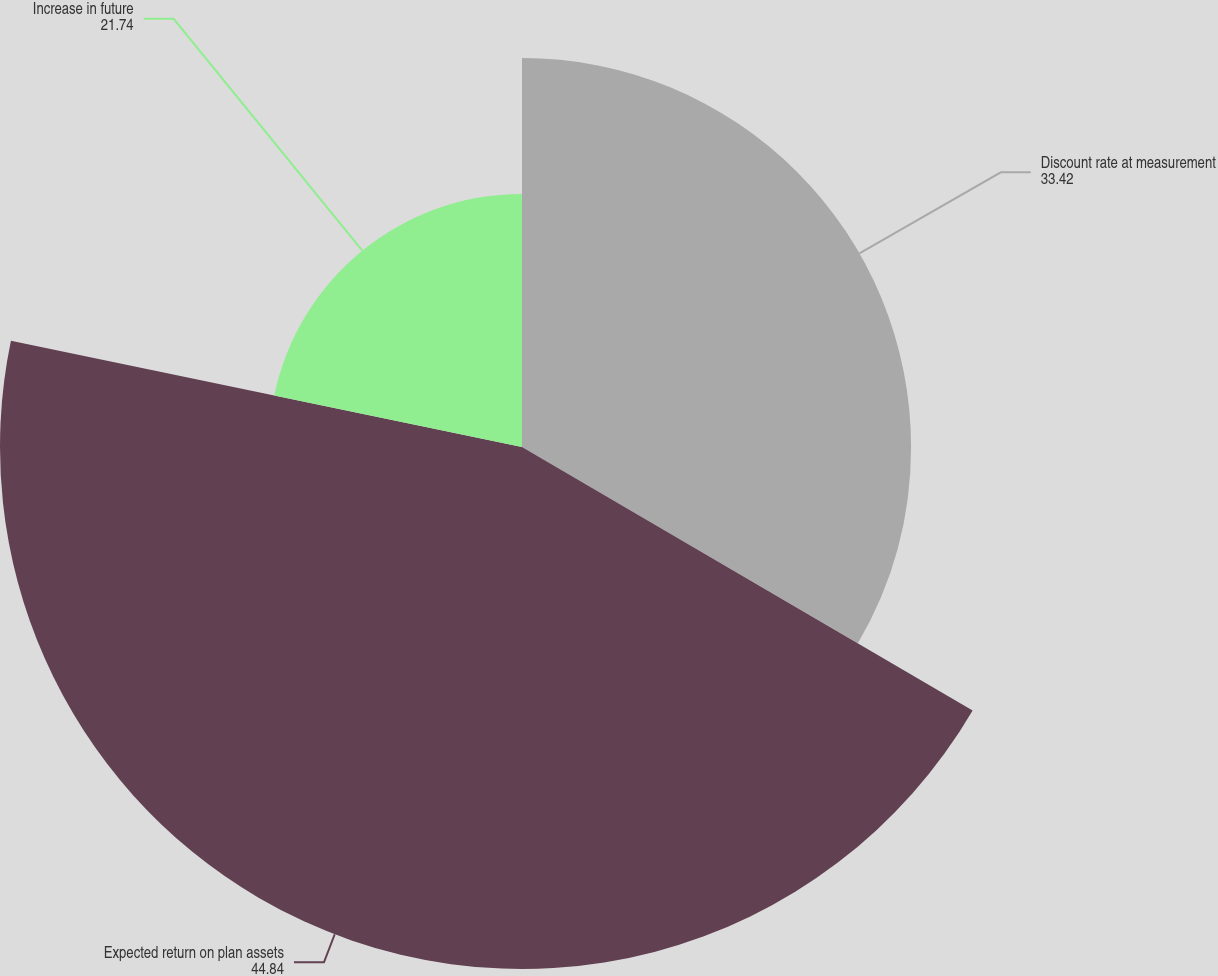Convert chart. <chart><loc_0><loc_0><loc_500><loc_500><pie_chart><fcel>Discount rate at measurement<fcel>Expected return on plan assets<fcel>Increase in future<nl><fcel>33.42%<fcel>44.84%<fcel>21.74%<nl></chart> 